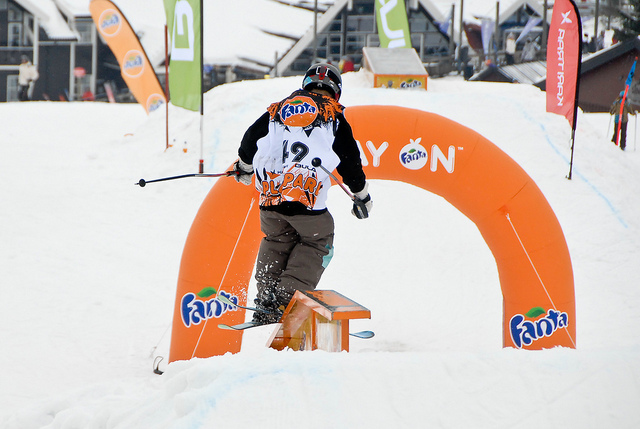Read all the text in this image. Fanta ON Fanta Fanta B Y 49 PARI 